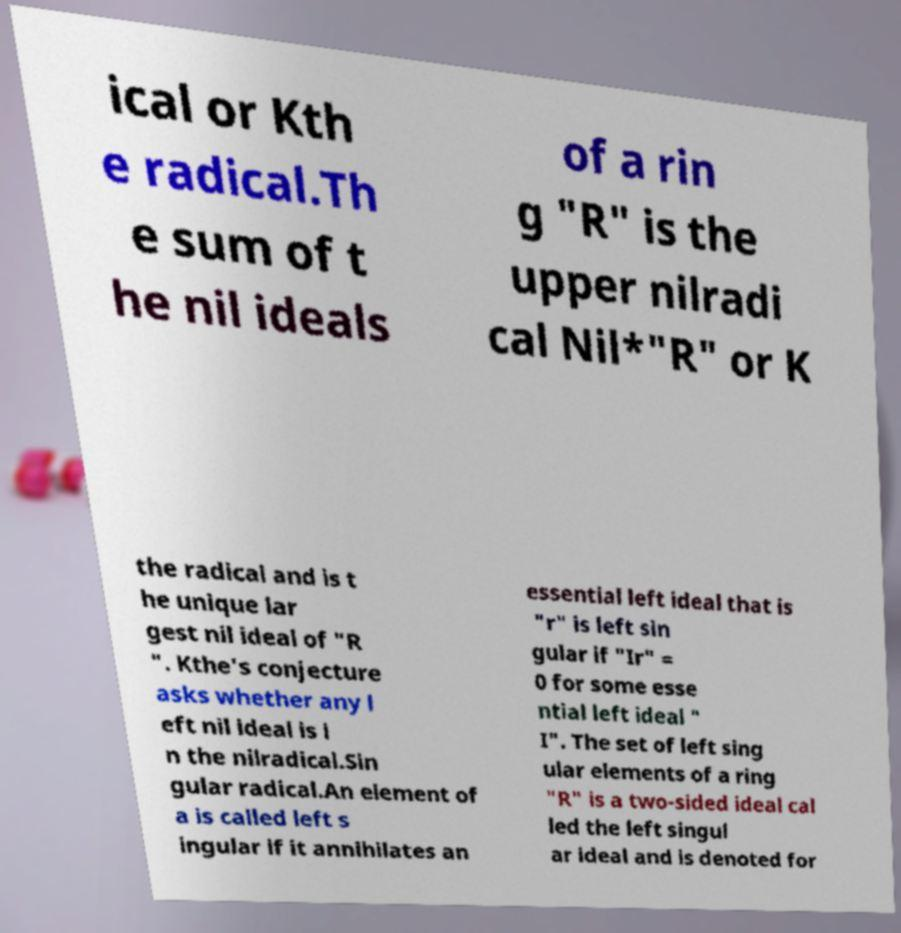I need the written content from this picture converted into text. Can you do that? ical or Kth e radical.Th e sum of t he nil ideals of a rin g "R" is the upper nilradi cal Nil*"R" or K the radical and is t he unique lar gest nil ideal of "R ". Kthe's conjecture asks whether any l eft nil ideal is i n the nilradical.Sin gular radical.An element of a is called left s ingular if it annihilates an essential left ideal that is "r" is left sin gular if "Ir" = 0 for some esse ntial left ideal " I". The set of left sing ular elements of a ring "R" is a two-sided ideal cal led the left singul ar ideal and is denoted for 